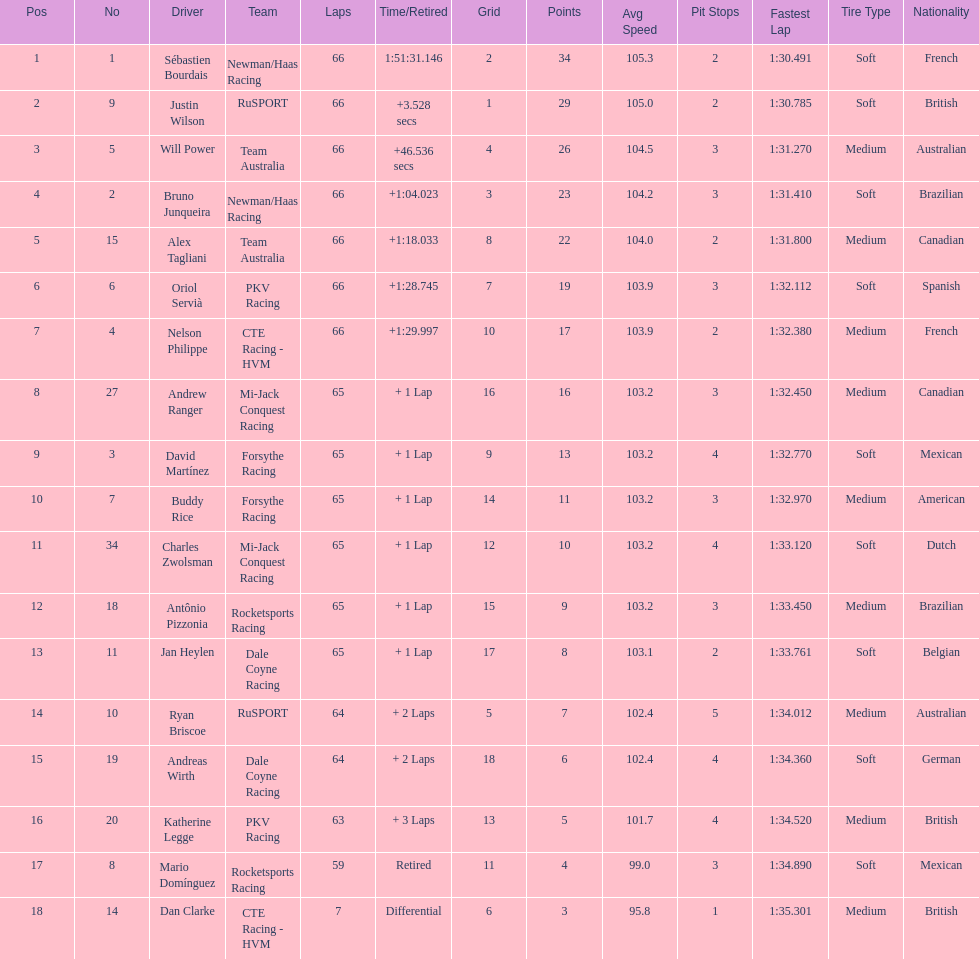Write the full table. {'header': ['Pos', 'No', 'Driver', 'Team', 'Laps', 'Time/Retired', 'Grid', 'Points', 'Avg Speed', 'Pit Stops', 'Fastest Lap', 'Tire Type', 'Nationality'], 'rows': [['1', '1', 'Sébastien Bourdais', 'Newman/Haas Racing', '66', '1:51:31.146', '2', '34', '105.3', '2', '1:30.491', 'Soft', 'French'], ['2', '9', 'Justin Wilson', 'RuSPORT', '66', '+3.528 secs', '1', '29', '105.0', '2', '1:30.785', 'Soft', 'British'], ['3', '5', 'Will Power', 'Team Australia', '66', '+46.536 secs', '4', '26', '104.5', '3', '1:31.270', 'Medium', 'Australian'], ['4', '2', 'Bruno Junqueira', 'Newman/Haas Racing', '66', '+1:04.023', '3', '23', '104.2', '3', '1:31.410', 'Soft', 'Brazilian'], ['5', '15', 'Alex Tagliani', 'Team Australia', '66', '+1:18.033', '8', '22', '104.0', '2', '1:31.800', 'Medium', 'Canadian'], ['6', '6', 'Oriol Servià', 'PKV Racing', '66', '+1:28.745', '7', '19', '103.9', '3', '1:32.112', 'Soft', 'Spanish'], ['7', '4', 'Nelson Philippe', 'CTE Racing - HVM', '66', '+1:29.997', '10', '17', '103.9', '2', '1:32.380', 'Medium', 'French'], ['8', '27', 'Andrew Ranger', 'Mi-Jack Conquest Racing', '65', '+ 1 Lap', '16', '16', '103.2', '3', '1:32.450', 'Medium', 'Canadian'], ['9', '3', 'David Martínez', 'Forsythe Racing', '65', '+ 1 Lap', '9', '13', '103.2', '4', '1:32.770', 'Soft', 'Mexican'], ['10', '7', 'Buddy Rice', 'Forsythe Racing', '65', '+ 1 Lap', '14', '11', '103.2', '3', '1:32.970', 'Medium', 'American'], ['11', '34', 'Charles Zwolsman', 'Mi-Jack Conquest Racing', '65', '+ 1 Lap', '12', '10', '103.2', '4', '1:33.120', 'Soft', 'Dutch'], ['12', '18', 'Antônio Pizzonia', 'Rocketsports Racing', '65', '+ 1 Lap', '15', '9', '103.2', '3', '1:33.450', 'Medium', 'Brazilian'], ['13', '11', 'Jan Heylen', 'Dale Coyne Racing', '65', '+ 1 Lap', '17', '8', '103.1', '2', '1:33.761', 'Soft', 'Belgian'], ['14', '10', 'Ryan Briscoe', 'RuSPORT', '64', '+ 2 Laps', '5', '7', '102.4', '5', '1:34.012', 'Medium', 'Australian'], ['15', '19', 'Andreas Wirth', 'Dale Coyne Racing', '64', '+ 2 Laps', '18', '6', '102.4', '4', '1:34.360', 'Soft', 'German'], ['16', '20', 'Katherine Legge', 'PKV Racing', '63', '+ 3 Laps', '13', '5', '101.7', '4', '1:34.520', 'Medium', 'British'], ['17', '8', 'Mario Domínguez', 'Rocketsports Racing', '59', 'Retired', '11', '4', '99.0', '3', '1:34.890', 'Soft', 'Mexican'], ['18', '14', 'Dan Clarke', 'CTE Racing - HVM', '7', 'Differential', '6', '3', '95.8', '1', '1:35.301', 'Medium', 'British']]} At the 2006 gran premio telmex, who finished last? Dan Clarke. 